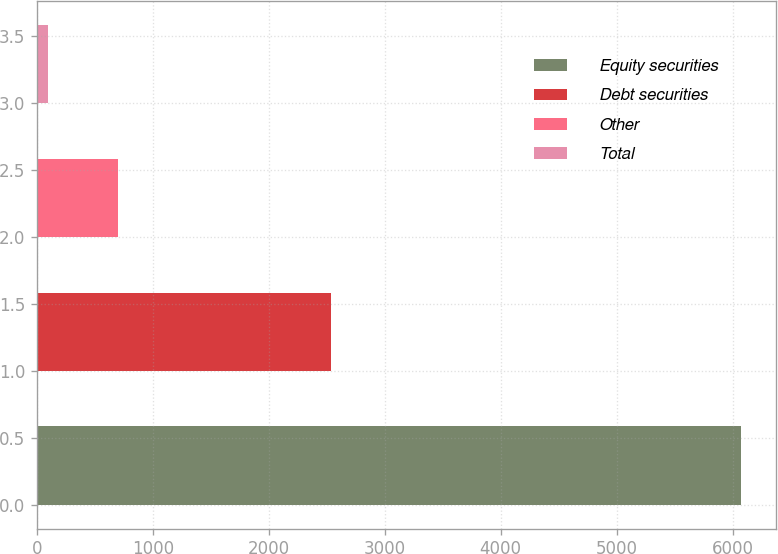Convert chart to OTSL. <chart><loc_0><loc_0><loc_500><loc_500><bar_chart><fcel>Equity securities<fcel>Debt securities<fcel>Other<fcel>Total<nl><fcel>6070<fcel>2535<fcel>697<fcel>100<nl></chart> 